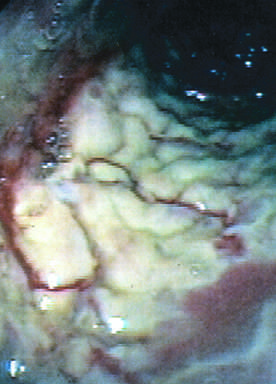s the colon coated by tan pseudomembranes composed of neutrophils, dead epithelial cells, and inflammatory debris endoscopic view?
Answer the question using a single word or phrase. Yes 